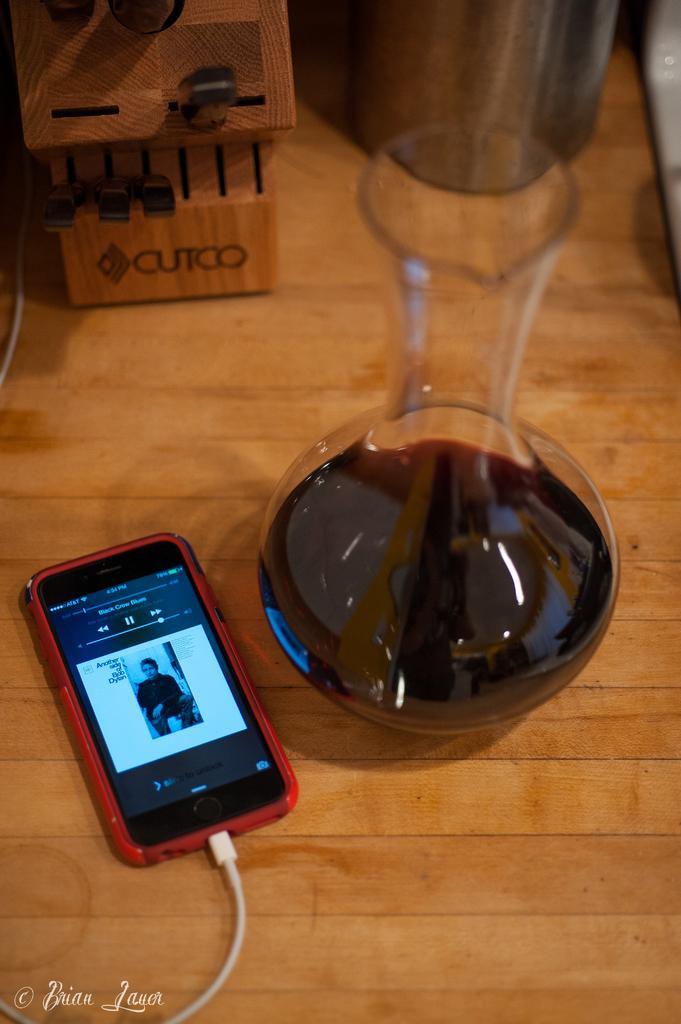Is this person getting drunk and drunk dialing?
Your answer should be compact. Unanswerable. What brand is the butcher block?
Make the answer very short. Cutco. 